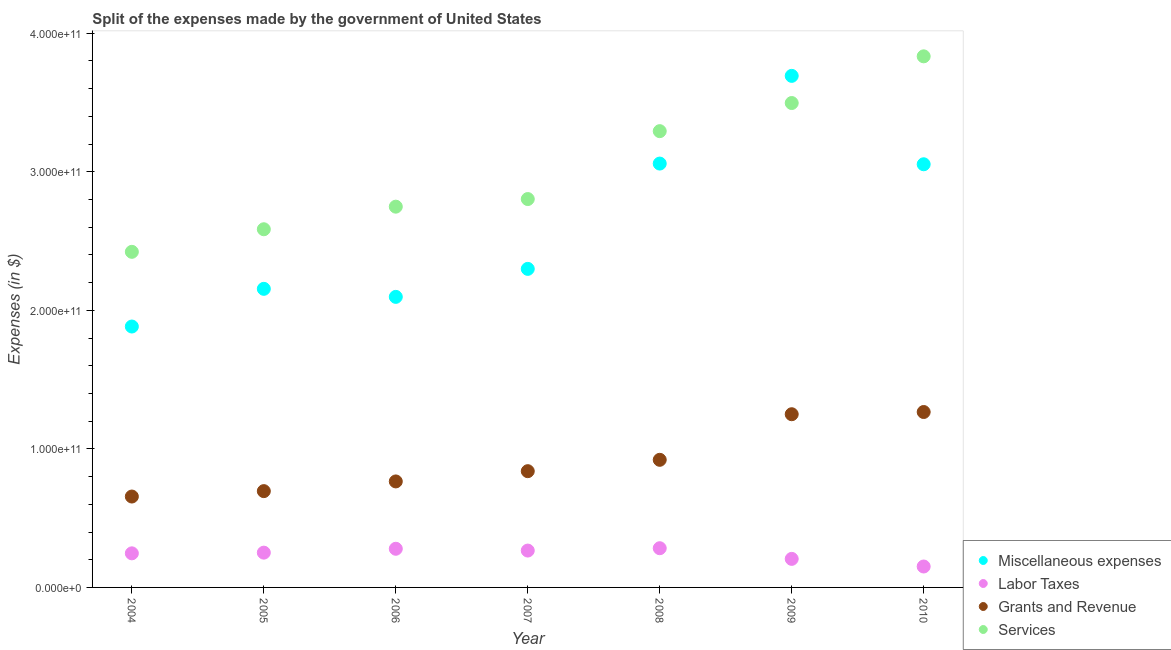What is the amount spent on services in 2007?
Your answer should be very brief. 2.80e+11. Across all years, what is the maximum amount spent on labor taxes?
Offer a very short reply. 2.83e+1. Across all years, what is the minimum amount spent on miscellaneous expenses?
Offer a terse response. 1.88e+11. In which year was the amount spent on grants and revenue maximum?
Your response must be concise. 2010. What is the total amount spent on grants and revenue in the graph?
Provide a succinct answer. 6.39e+11. What is the difference between the amount spent on miscellaneous expenses in 2005 and that in 2007?
Make the answer very short. -1.44e+1. What is the difference between the amount spent on miscellaneous expenses in 2007 and the amount spent on grants and revenue in 2006?
Offer a terse response. 1.53e+11. What is the average amount spent on labor taxes per year?
Offer a terse response. 2.40e+1. In the year 2004, what is the difference between the amount spent on grants and revenue and amount spent on miscellaneous expenses?
Your response must be concise. -1.23e+11. What is the ratio of the amount spent on services in 2004 to that in 2010?
Your response must be concise. 0.63. Is the amount spent on services in 2009 less than that in 2010?
Offer a very short reply. Yes. Is the difference between the amount spent on services in 2007 and 2008 greater than the difference between the amount spent on grants and revenue in 2007 and 2008?
Offer a terse response. No. What is the difference between the highest and the second highest amount spent on services?
Offer a terse response. 3.37e+1. What is the difference between the highest and the lowest amount spent on miscellaneous expenses?
Ensure brevity in your answer.  1.81e+11. Is it the case that in every year, the sum of the amount spent on services and amount spent on grants and revenue is greater than the sum of amount spent on miscellaneous expenses and amount spent on labor taxes?
Your response must be concise. Yes. Is it the case that in every year, the sum of the amount spent on miscellaneous expenses and amount spent on labor taxes is greater than the amount spent on grants and revenue?
Provide a succinct answer. Yes. Does the amount spent on grants and revenue monotonically increase over the years?
Your answer should be compact. Yes. Is the amount spent on labor taxes strictly greater than the amount spent on services over the years?
Keep it short and to the point. No. How many dotlines are there?
Your answer should be compact. 4. What is the difference between two consecutive major ticks on the Y-axis?
Your answer should be very brief. 1.00e+11. Are the values on the major ticks of Y-axis written in scientific E-notation?
Your answer should be compact. Yes. Does the graph contain grids?
Provide a succinct answer. No. Where does the legend appear in the graph?
Your answer should be compact. Bottom right. How are the legend labels stacked?
Keep it short and to the point. Vertical. What is the title of the graph?
Your response must be concise. Split of the expenses made by the government of United States. What is the label or title of the Y-axis?
Keep it short and to the point. Expenses (in $). What is the Expenses (in $) of Miscellaneous expenses in 2004?
Keep it short and to the point. 1.88e+11. What is the Expenses (in $) of Labor Taxes in 2004?
Give a very brief answer. 2.46e+1. What is the Expenses (in $) of Grants and Revenue in 2004?
Your answer should be very brief. 6.56e+1. What is the Expenses (in $) of Services in 2004?
Keep it short and to the point. 2.42e+11. What is the Expenses (in $) of Miscellaneous expenses in 2005?
Your answer should be compact. 2.16e+11. What is the Expenses (in $) of Labor Taxes in 2005?
Make the answer very short. 2.51e+1. What is the Expenses (in $) in Grants and Revenue in 2005?
Your answer should be compact. 6.95e+1. What is the Expenses (in $) in Services in 2005?
Make the answer very short. 2.58e+11. What is the Expenses (in $) of Miscellaneous expenses in 2006?
Provide a short and direct response. 2.10e+11. What is the Expenses (in $) of Labor Taxes in 2006?
Your answer should be very brief. 2.79e+1. What is the Expenses (in $) of Grants and Revenue in 2006?
Your answer should be very brief. 7.65e+1. What is the Expenses (in $) of Services in 2006?
Your response must be concise. 2.75e+11. What is the Expenses (in $) in Miscellaneous expenses in 2007?
Offer a very short reply. 2.30e+11. What is the Expenses (in $) of Labor Taxes in 2007?
Give a very brief answer. 2.66e+1. What is the Expenses (in $) of Grants and Revenue in 2007?
Your response must be concise. 8.39e+1. What is the Expenses (in $) in Services in 2007?
Offer a very short reply. 2.80e+11. What is the Expenses (in $) of Miscellaneous expenses in 2008?
Your response must be concise. 3.06e+11. What is the Expenses (in $) of Labor Taxes in 2008?
Provide a short and direct response. 2.83e+1. What is the Expenses (in $) in Grants and Revenue in 2008?
Your response must be concise. 9.21e+1. What is the Expenses (in $) of Services in 2008?
Give a very brief answer. 3.29e+11. What is the Expenses (in $) of Miscellaneous expenses in 2009?
Your response must be concise. 3.69e+11. What is the Expenses (in $) in Labor Taxes in 2009?
Keep it short and to the point. 2.06e+1. What is the Expenses (in $) of Grants and Revenue in 2009?
Your answer should be compact. 1.25e+11. What is the Expenses (in $) of Services in 2009?
Ensure brevity in your answer.  3.50e+11. What is the Expenses (in $) in Miscellaneous expenses in 2010?
Ensure brevity in your answer.  3.05e+11. What is the Expenses (in $) in Labor Taxes in 2010?
Keep it short and to the point. 1.51e+1. What is the Expenses (in $) of Grants and Revenue in 2010?
Offer a terse response. 1.27e+11. What is the Expenses (in $) in Services in 2010?
Give a very brief answer. 3.83e+11. Across all years, what is the maximum Expenses (in $) in Miscellaneous expenses?
Give a very brief answer. 3.69e+11. Across all years, what is the maximum Expenses (in $) in Labor Taxes?
Provide a short and direct response. 2.83e+1. Across all years, what is the maximum Expenses (in $) in Grants and Revenue?
Provide a short and direct response. 1.27e+11. Across all years, what is the maximum Expenses (in $) in Services?
Your answer should be very brief. 3.83e+11. Across all years, what is the minimum Expenses (in $) in Miscellaneous expenses?
Make the answer very short. 1.88e+11. Across all years, what is the minimum Expenses (in $) of Labor Taxes?
Keep it short and to the point. 1.51e+1. Across all years, what is the minimum Expenses (in $) in Grants and Revenue?
Keep it short and to the point. 6.56e+1. Across all years, what is the minimum Expenses (in $) in Services?
Provide a short and direct response. 2.42e+11. What is the total Expenses (in $) in Miscellaneous expenses in the graph?
Provide a succinct answer. 1.82e+12. What is the total Expenses (in $) of Labor Taxes in the graph?
Your response must be concise. 1.68e+11. What is the total Expenses (in $) of Grants and Revenue in the graph?
Provide a succinct answer. 6.39e+11. What is the total Expenses (in $) of Services in the graph?
Offer a very short reply. 2.12e+12. What is the difference between the Expenses (in $) of Miscellaneous expenses in 2004 and that in 2005?
Provide a succinct answer. -2.72e+1. What is the difference between the Expenses (in $) of Labor Taxes in 2004 and that in 2005?
Provide a short and direct response. -5.00e+08. What is the difference between the Expenses (in $) of Grants and Revenue in 2004 and that in 2005?
Make the answer very short. -3.90e+09. What is the difference between the Expenses (in $) of Services in 2004 and that in 2005?
Provide a short and direct response. -1.63e+1. What is the difference between the Expenses (in $) of Miscellaneous expenses in 2004 and that in 2006?
Offer a very short reply. -2.14e+1. What is the difference between the Expenses (in $) in Labor Taxes in 2004 and that in 2006?
Make the answer very short. -3.30e+09. What is the difference between the Expenses (in $) in Grants and Revenue in 2004 and that in 2006?
Make the answer very short. -1.09e+1. What is the difference between the Expenses (in $) of Services in 2004 and that in 2006?
Your response must be concise. -3.26e+1. What is the difference between the Expenses (in $) in Miscellaneous expenses in 2004 and that in 2007?
Your answer should be very brief. -4.16e+1. What is the difference between the Expenses (in $) in Labor Taxes in 2004 and that in 2007?
Your answer should be compact. -2.00e+09. What is the difference between the Expenses (in $) in Grants and Revenue in 2004 and that in 2007?
Offer a very short reply. -1.83e+1. What is the difference between the Expenses (in $) in Services in 2004 and that in 2007?
Provide a succinct answer. -3.81e+1. What is the difference between the Expenses (in $) of Miscellaneous expenses in 2004 and that in 2008?
Provide a short and direct response. -1.18e+11. What is the difference between the Expenses (in $) of Labor Taxes in 2004 and that in 2008?
Your response must be concise. -3.70e+09. What is the difference between the Expenses (in $) of Grants and Revenue in 2004 and that in 2008?
Offer a terse response. -2.65e+1. What is the difference between the Expenses (in $) of Services in 2004 and that in 2008?
Your answer should be compact. -8.71e+1. What is the difference between the Expenses (in $) of Miscellaneous expenses in 2004 and that in 2009?
Ensure brevity in your answer.  -1.81e+11. What is the difference between the Expenses (in $) of Labor Taxes in 2004 and that in 2009?
Provide a short and direct response. 4.00e+09. What is the difference between the Expenses (in $) of Grants and Revenue in 2004 and that in 2009?
Your response must be concise. -5.94e+1. What is the difference between the Expenses (in $) in Services in 2004 and that in 2009?
Your answer should be compact. -1.07e+11. What is the difference between the Expenses (in $) of Miscellaneous expenses in 2004 and that in 2010?
Your response must be concise. -1.17e+11. What is the difference between the Expenses (in $) in Labor Taxes in 2004 and that in 2010?
Make the answer very short. 9.50e+09. What is the difference between the Expenses (in $) in Grants and Revenue in 2004 and that in 2010?
Give a very brief answer. -6.10e+1. What is the difference between the Expenses (in $) in Services in 2004 and that in 2010?
Give a very brief answer. -1.41e+11. What is the difference between the Expenses (in $) in Miscellaneous expenses in 2005 and that in 2006?
Provide a succinct answer. 5.80e+09. What is the difference between the Expenses (in $) of Labor Taxes in 2005 and that in 2006?
Your answer should be compact. -2.80e+09. What is the difference between the Expenses (in $) in Grants and Revenue in 2005 and that in 2006?
Your response must be concise. -7.00e+09. What is the difference between the Expenses (in $) in Services in 2005 and that in 2006?
Your response must be concise. -1.63e+1. What is the difference between the Expenses (in $) in Miscellaneous expenses in 2005 and that in 2007?
Offer a very short reply. -1.44e+1. What is the difference between the Expenses (in $) in Labor Taxes in 2005 and that in 2007?
Your answer should be compact. -1.50e+09. What is the difference between the Expenses (in $) in Grants and Revenue in 2005 and that in 2007?
Your answer should be very brief. -1.44e+1. What is the difference between the Expenses (in $) of Services in 2005 and that in 2007?
Offer a very short reply. -2.18e+1. What is the difference between the Expenses (in $) of Miscellaneous expenses in 2005 and that in 2008?
Give a very brief answer. -9.04e+1. What is the difference between the Expenses (in $) of Labor Taxes in 2005 and that in 2008?
Give a very brief answer. -3.20e+09. What is the difference between the Expenses (in $) in Grants and Revenue in 2005 and that in 2008?
Offer a terse response. -2.26e+1. What is the difference between the Expenses (in $) of Services in 2005 and that in 2008?
Ensure brevity in your answer.  -7.08e+1. What is the difference between the Expenses (in $) in Miscellaneous expenses in 2005 and that in 2009?
Make the answer very short. -1.54e+11. What is the difference between the Expenses (in $) of Labor Taxes in 2005 and that in 2009?
Offer a terse response. 4.50e+09. What is the difference between the Expenses (in $) of Grants and Revenue in 2005 and that in 2009?
Provide a short and direct response. -5.55e+1. What is the difference between the Expenses (in $) in Services in 2005 and that in 2009?
Ensure brevity in your answer.  -9.11e+1. What is the difference between the Expenses (in $) of Miscellaneous expenses in 2005 and that in 2010?
Give a very brief answer. -8.99e+1. What is the difference between the Expenses (in $) of Grants and Revenue in 2005 and that in 2010?
Give a very brief answer. -5.71e+1. What is the difference between the Expenses (in $) of Services in 2005 and that in 2010?
Provide a succinct answer. -1.25e+11. What is the difference between the Expenses (in $) of Miscellaneous expenses in 2006 and that in 2007?
Provide a short and direct response. -2.02e+1. What is the difference between the Expenses (in $) in Labor Taxes in 2006 and that in 2007?
Keep it short and to the point. 1.30e+09. What is the difference between the Expenses (in $) of Grants and Revenue in 2006 and that in 2007?
Provide a succinct answer. -7.40e+09. What is the difference between the Expenses (in $) of Services in 2006 and that in 2007?
Offer a terse response. -5.50e+09. What is the difference between the Expenses (in $) in Miscellaneous expenses in 2006 and that in 2008?
Offer a terse response. -9.62e+1. What is the difference between the Expenses (in $) in Labor Taxes in 2006 and that in 2008?
Provide a short and direct response. -4.00e+08. What is the difference between the Expenses (in $) of Grants and Revenue in 2006 and that in 2008?
Provide a succinct answer. -1.56e+1. What is the difference between the Expenses (in $) of Services in 2006 and that in 2008?
Provide a succinct answer. -5.45e+1. What is the difference between the Expenses (in $) of Miscellaneous expenses in 2006 and that in 2009?
Ensure brevity in your answer.  -1.60e+11. What is the difference between the Expenses (in $) in Labor Taxes in 2006 and that in 2009?
Provide a succinct answer. 7.30e+09. What is the difference between the Expenses (in $) in Grants and Revenue in 2006 and that in 2009?
Offer a very short reply. -4.85e+1. What is the difference between the Expenses (in $) in Services in 2006 and that in 2009?
Ensure brevity in your answer.  -7.48e+1. What is the difference between the Expenses (in $) in Miscellaneous expenses in 2006 and that in 2010?
Your response must be concise. -9.57e+1. What is the difference between the Expenses (in $) in Labor Taxes in 2006 and that in 2010?
Your answer should be very brief. 1.28e+1. What is the difference between the Expenses (in $) in Grants and Revenue in 2006 and that in 2010?
Offer a very short reply. -5.01e+1. What is the difference between the Expenses (in $) in Services in 2006 and that in 2010?
Ensure brevity in your answer.  -1.08e+11. What is the difference between the Expenses (in $) of Miscellaneous expenses in 2007 and that in 2008?
Your answer should be compact. -7.60e+1. What is the difference between the Expenses (in $) of Labor Taxes in 2007 and that in 2008?
Provide a succinct answer. -1.70e+09. What is the difference between the Expenses (in $) of Grants and Revenue in 2007 and that in 2008?
Provide a succinct answer. -8.20e+09. What is the difference between the Expenses (in $) in Services in 2007 and that in 2008?
Provide a short and direct response. -4.90e+1. What is the difference between the Expenses (in $) in Miscellaneous expenses in 2007 and that in 2009?
Provide a succinct answer. -1.39e+11. What is the difference between the Expenses (in $) in Labor Taxes in 2007 and that in 2009?
Your answer should be very brief. 6.00e+09. What is the difference between the Expenses (in $) of Grants and Revenue in 2007 and that in 2009?
Provide a short and direct response. -4.11e+1. What is the difference between the Expenses (in $) of Services in 2007 and that in 2009?
Your answer should be compact. -6.93e+1. What is the difference between the Expenses (in $) of Miscellaneous expenses in 2007 and that in 2010?
Offer a very short reply. -7.55e+1. What is the difference between the Expenses (in $) in Labor Taxes in 2007 and that in 2010?
Your answer should be compact. 1.15e+1. What is the difference between the Expenses (in $) in Grants and Revenue in 2007 and that in 2010?
Provide a short and direct response. -4.27e+1. What is the difference between the Expenses (in $) in Services in 2007 and that in 2010?
Your response must be concise. -1.03e+11. What is the difference between the Expenses (in $) of Miscellaneous expenses in 2008 and that in 2009?
Make the answer very short. -6.33e+1. What is the difference between the Expenses (in $) of Labor Taxes in 2008 and that in 2009?
Your answer should be compact. 7.70e+09. What is the difference between the Expenses (in $) in Grants and Revenue in 2008 and that in 2009?
Your response must be concise. -3.29e+1. What is the difference between the Expenses (in $) in Services in 2008 and that in 2009?
Make the answer very short. -2.03e+1. What is the difference between the Expenses (in $) in Labor Taxes in 2008 and that in 2010?
Provide a short and direct response. 1.32e+1. What is the difference between the Expenses (in $) in Grants and Revenue in 2008 and that in 2010?
Make the answer very short. -3.45e+1. What is the difference between the Expenses (in $) of Services in 2008 and that in 2010?
Make the answer very short. -5.40e+1. What is the difference between the Expenses (in $) of Miscellaneous expenses in 2009 and that in 2010?
Make the answer very short. 6.38e+1. What is the difference between the Expenses (in $) in Labor Taxes in 2009 and that in 2010?
Your answer should be compact. 5.50e+09. What is the difference between the Expenses (in $) of Grants and Revenue in 2009 and that in 2010?
Keep it short and to the point. -1.60e+09. What is the difference between the Expenses (in $) in Services in 2009 and that in 2010?
Your response must be concise. -3.37e+1. What is the difference between the Expenses (in $) in Miscellaneous expenses in 2004 and the Expenses (in $) in Labor Taxes in 2005?
Your answer should be compact. 1.63e+11. What is the difference between the Expenses (in $) in Miscellaneous expenses in 2004 and the Expenses (in $) in Grants and Revenue in 2005?
Ensure brevity in your answer.  1.19e+11. What is the difference between the Expenses (in $) in Miscellaneous expenses in 2004 and the Expenses (in $) in Services in 2005?
Your answer should be compact. -7.02e+1. What is the difference between the Expenses (in $) in Labor Taxes in 2004 and the Expenses (in $) in Grants and Revenue in 2005?
Offer a very short reply. -4.49e+1. What is the difference between the Expenses (in $) in Labor Taxes in 2004 and the Expenses (in $) in Services in 2005?
Make the answer very short. -2.34e+11. What is the difference between the Expenses (in $) in Grants and Revenue in 2004 and the Expenses (in $) in Services in 2005?
Your response must be concise. -1.93e+11. What is the difference between the Expenses (in $) of Miscellaneous expenses in 2004 and the Expenses (in $) of Labor Taxes in 2006?
Provide a succinct answer. 1.60e+11. What is the difference between the Expenses (in $) of Miscellaneous expenses in 2004 and the Expenses (in $) of Grants and Revenue in 2006?
Offer a terse response. 1.12e+11. What is the difference between the Expenses (in $) in Miscellaneous expenses in 2004 and the Expenses (in $) in Services in 2006?
Make the answer very short. -8.65e+1. What is the difference between the Expenses (in $) of Labor Taxes in 2004 and the Expenses (in $) of Grants and Revenue in 2006?
Offer a very short reply. -5.19e+1. What is the difference between the Expenses (in $) in Labor Taxes in 2004 and the Expenses (in $) in Services in 2006?
Give a very brief answer. -2.50e+11. What is the difference between the Expenses (in $) in Grants and Revenue in 2004 and the Expenses (in $) in Services in 2006?
Your response must be concise. -2.09e+11. What is the difference between the Expenses (in $) in Miscellaneous expenses in 2004 and the Expenses (in $) in Labor Taxes in 2007?
Your answer should be very brief. 1.62e+11. What is the difference between the Expenses (in $) in Miscellaneous expenses in 2004 and the Expenses (in $) in Grants and Revenue in 2007?
Make the answer very short. 1.04e+11. What is the difference between the Expenses (in $) of Miscellaneous expenses in 2004 and the Expenses (in $) of Services in 2007?
Keep it short and to the point. -9.20e+1. What is the difference between the Expenses (in $) of Labor Taxes in 2004 and the Expenses (in $) of Grants and Revenue in 2007?
Give a very brief answer. -5.93e+1. What is the difference between the Expenses (in $) in Labor Taxes in 2004 and the Expenses (in $) in Services in 2007?
Provide a short and direct response. -2.56e+11. What is the difference between the Expenses (in $) in Grants and Revenue in 2004 and the Expenses (in $) in Services in 2007?
Your response must be concise. -2.15e+11. What is the difference between the Expenses (in $) in Miscellaneous expenses in 2004 and the Expenses (in $) in Labor Taxes in 2008?
Your response must be concise. 1.60e+11. What is the difference between the Expenses (in $) of Miscellaneous expenses in 2004 and the Expenses (in $) of Grants and Revenue in 2008?
Your answer should be very brief. 9.62e+1. What is the difference between the Expenses (in $) of Miscellaneous expenses in 2004 and the Expenses (in $) of Services in 2008?
Ensure brevity in your answer.  -1.41e+11. What is the difference between the Expenses (in $) of Labor Taxes in 2004 and the Expenses (in $) of Grants and Revenue in 2008?
Provide a succinct answer. -6.75e+1. What is the difference between the Expenses (in $) of Labor Taxes in 2004 and the Expenses (in $) of Services in 2008?
Your answer should be compact. -3.05e+11. What is the difference between the Expenses (in $) in Grants and Revenue in 2004 and the Expenses (in $) in Services in 2008?
Your answer should be very brief. -2.64e+11. What is the difference between the Expenses (in $) in Miscellaneous expenses in 2004 and the Expenses (in $) in Labor Taxes in 2009?
Ensure brevity in your answer.  1.68e+11. What is the difference between the Expenses (in $) in Miscellaneous expenses in 2004 and the Expenses (in $) in Grants and Revenue in 2009?
Offer a terse response. 6.33e+1. What is the difference between the Expenses (in $) in Miscellaneous expenses in 2004 and the Expenses (in $) in Services in 2009?
Give a very brief answer. -1.61e+11. What is the difference between the Expenses (in $) in Labor Taxes in 2004 and the Expenses (in $) in Grants and Revenue in 2009?
Offer a very short reply. -1.00e+11. What is the difference between the Expenses (in $) of Labor Taxes in 2004 and the Expenses (in $) of Services in 2009?
Your response must be concise. -3.25e+11. What is the difference between the Expenses (in $) in Grants and Revenue in 2004 and the Expenses (in $) in Services in 2009?
Give a very brief answer. -2.84e+11. What is the difference between the Expenses (in $) in Miscellaneous expenses in 2004 and the Expenses (in $) in Labor Taxes in 2010?
Make the answer very short. 1.73e+11. What is the difference between the Expenses (in $) in Miscellaneous expenses in 2004 and the Expenses (in $) in Grants and Revenue in 2010?
Make the answer very short. 6.17e+1. What is the difference between the Expenses (in $) in Miscellaneous expenses in 2004 and the Expenses (in $) in Services in 2010?
Offer a very short reply. -1.95e+11. What is the difference between the Expenses (in $) of Labor Taxes in 2004 and the Expenses (in $) of Grants and Revenue in 2010?
Give a very brief answer. -1.02e+11. What is the difference between the Expenses (in $) of Labor Taxes in 2004 and the Expenses (in $) of Services in 2010?
Offer a terse response. -3.59e+11. What is the difference between the Expenses (in $) of Grants and Revenue in 2004 and the Expenses (in $) of Services in 2010?
Your answer should be very brief. -3.18e+11. What is the difference between the Expenses (in $) in Miscellaneous expenses in 2005 and the Expenses (in $) in Labor Taxes in 2006?
Give a very brief answer. 1.88e+11. What is the difference between the Expenses (in $) of Miscellaneous expenses in 2005 and the Expenses (in $) of Grants and Revenue in 2006?
Your answer should be compact. 1.39e+11. What is the difference between the Expenses (in $) in Miscellaneous expenses in 2005 and the Expenses (in $) in Services in 2006?
Ensure brevity in your answer.  -5.93e+1. What is the difference between the Expenses (in $) in Labor Taxes in 2005 and the Expenses (in $) in Grants and Revenue in 2006?
Offer a terse response. -5.14e+1. What is the difference between the Expenses (in $) of Labor Taxes in 2005 and the Expenses (in $) of Services in 2006?
Your answer should be compact. -2.50e+11. What is the difference between the Expenses (in $) of Grants and Revenue in 2005 and the Expenses (in $) of Services in 2006?
Make the answer very short. -2.05e+11. What is the difference between the Expenses (in $) of Miscellaneous expenses in 2005 and the Expenses (in $) of Labor Taxes in 2007?
Give a very brief answer. 1.89e+11. What is the difference between the Expenses (in $) of Miscellaneous expenses in 2005 and the Expenses (in $) of Grants and Revenue in 2007?
Provide a succinct answer. 1.32e+11. What is the difference between the Expenses (in $) in Miscellaneous expenses in 2005 and the Expenses (in $) in Services in 2007?
Ensure brevity in your answer.  -6.48e+1. What is the difference between the Expenses (in $) in Labor Taxes in 2005 and the Expenses (in $) in Grants and Revenue in 2007?
Your answer should be compact. -5.88e+1. What is the difference between the Expenses (in $) of Labor Taxes in 2005 and the Expenses (in $) of Services in 2007?
Ensure brevity in your answer.  -2.55e+11. What is the difference between the Expenses (in $) of Grants and Revenue in 2005 and the Expenses (in $) of Services in 2007?
Provide a short and direct response. -2.11e+11. What is the difference between the Expenses (in $) in Miscellaneous expenses in 2005 and the Expenses (in $) in Labor Taxes in 2008?
Your answer should be very brief. 1.87e+11. What is the difference between the Expenses (in $) in Miscellaneous expenses in 2005 and the Expenses (in $) in Grants and Revenue in 2008?
Offer a very short reply. 1.23e+11. What is the difference between the Expenses (in $) in Miscellaneous expenses in 2005 and the Expenses (in $) in Services in 2008?
Your answer should be compact. -1.14e+11. What is the difference between the Expenses (in $) in Labor Taxes in 2005 and the Expenses (in $) in Grants and Revenue in 2008?
Your answer should be very brief. -6.70e+1. What is the difference between the Expenses (in $) of Labor Taxes in 2005 and the Expenses (in $) of Services in 2008?
Provide a short and direct response. -3.04e+11. What is the difference between the Expenses (in $) in Grants and Revenue in 2005 and the Expenses (in $) in Services in 2008?
Give a very brief answer. -2.60e+11. What is the difference between the Expenses (in $) of Miscellaneous expenses in 2005 and the Expenses (in $) of Labor Taxes in 2009?
Provide a short and direct response. 1.95e+11. What is the difference between the Expenses (in $) in Miscellaneous expenses in 2005 and the Expenses (in $) in Grants and Revenue in 2009?
Give a very brief answer. 9.05e+1. What is the difference between the Expenses (in $) in Miscellaneous expenses in 2005 and the Expenses (in $) in Services in 2009?
Make the answer very short. -1.34e+11. What is the difference between the Expenses (in $) of Labor Taxes in 2005 and the Expenses (in $) of Grants and Revenue in 2009?
Keep it short and to the point. -9.99e+1. What is the difference between the Expenses (in $) of Labor Taxes in 2005 and the Expenses (in $) of Services in 2009?
Ensure brevity in your answer.  -3.24e+11. What is the difference between the Expenses (in $) of Grants and Revenue in 2005 and the Expenses (in $) of Services in 2009?
Provide a short and direct response. -2.80e+11. What is the difference between the Expenses (in $) in Miscellaneous expenses in 2005 and the Expenses (in $) in Labor Taxes in 2010?
Your response must be concise. 2.00e+11. What is the difference between the Expenses (in $) of Miscellaneous expenses in 2005 and the Expenses (in $) of Grants and Revenue in 2010?
Ensure brevity in your answer.  8.89e+1. What is the difference between the Expenses (in $) of Miscellaneous expenses in 2005 and the Expenses (in $) of Services in 2010?
Offer a very short reply. -1.68e+11. What is the difference between the Expenses (in $) in Labor Taxes in 2005 and the Expenses (in $) in Grants and Revenue in 2010?
Give a very brief answer. -1.02e+11. What is the difference between the Expenses (in $) of Labor Taxes in 2005 and the Expenses (in $) of Services in 2010?
Your answer should be very brief. -3.58e+11. What is the difference between the Expenses (in $) of Grants and Revenue in 2005 and the Expenses (in $) of Services in 2010?
Offer a very short reply. -3.14e+11. What is the difference between the Expenses (in $) of Miscellaneous expenses in 2006 and the Expenses (in $) of Labor Taxes in 2007?
Keep it short and to the point. 1.83e+11. What is the difference between the Expenses (in $) of Miscellaneous expenses in 2006 and the Expenses (in $) of Grants and Revenue in 2007?
Offer a very short reply. 1.26e+11. What is the difference between the Expenses (in $) in Miscellaneous expenses in 2006 and the Expenses (in $) in Services in 2007?
Make the answer very short. -7.06e+1. What is the difference between the Expenses (in $) in Labor Taxes in 2006 and the Expenses (in $) in Grants and Revenue in 2007?
Your answer should be compact. -5.60e+1. What is the difference between the Expenses (in $) in Labor Taxes in 2006 and the Expenses (in $) in Services in 2007?
Give a very brief answer. -2.52e+11. What is the difference between the Expenses (in $) of Grants and Revenue in 2006 and the Expenses (in $) of Services in 2007?
Provide a short and direct response. -2.04e+11. What is the difference between the Expenses (in $) of Miscellaneous expenses in 2006 and the Expenses (in $) of Labor Taxes in 2008?
Provide a succinct answer. 1.81e+11. What is the difference between the Expenses (in $) in Miscellaneous expenses in 2006 and the Expenses (in $) in Grants and Revenue in 2008?
Give a very brief answer. 1.18e+11. What is the difference between the Expenses (in $) in Miscellaneous expenses in 2006 and the Expenses (in $) in Services in 2008?
Give a very brief answer. -1.20e+11. What is the difference between the Expenses (in $) of Labor Taxes in 2006 and the Expenses (in $) of Grants and Revenue in 2008?
Your response must be concise. -6.42e+1. What is the difference between the Expenses (in $) in Labor Taxes in 2006 and the Expenses (in $) in Services in 2008?
Your answer should be very brief. -3.01e+11. What is the difference between the Expenses (in $) in Grants and Revenue in 2006 and the Expenses (in $) in Services in 2008?
Give a very brief answer. -2.53e+11. What is the difference between the Expenses (in $) in Miscellaneous expenses in 2006 and the Expenses (in $) in Labor Taxes in 2009?
Provide a short and direct response. 1.89e+11. What is the difference between the Expenses (in $) in Miscellaneous expenses in 2006 and the Expenses (in $) in Grants and Revenue in 2009?
Offer a very short reply. 8.47e+1. What is the difference between the Expenses (in $) of Miscellaneous expenses in 2006 and the Expenses (in $) of Services in 2009?
Give a very brief answer. -1.40e+11. What is the difference between the Expenses (in $) in Labor Taxes in 2006 and the Expenses (in $) in Grants and Revenue in 2009?
Offer a terse response. -9.71e+1. What is the difference between the Expenses (in $) of Labor Taxes in 2006 and the Expenses (in $) of Services in 2009?
Offer a terse response. -3.22e+11. What is the difference between the Expenses (in $) of Grants and Revenue in 2006 and the Expenses (in $) of Services in 2009?
Provide a succinct answer. -2.73e+11. What is the difference between the Expenses (in $) in Miscellaneous expenses in 2006 and the Expenses (in $) in Labor Taxes in 2010?
Make the answer very short. 1.95e+11. What is the difference between the Expenses (in $) in Miscellaneous expenses in 2006 and the Expenses (in $) in Grants and Revenue in 2010?
Your answer should be compact. 8.31e+1. What is the difference between the Expenses (in $) in Miscellaneous expenses in 2006 and the Expenses (in $) in Services in 2010?
Your response must be concise. -1.74e+11. What is the difference between the Expenses (in $) in Labor Taxes in 2006 and the Expenses (in $) in Grants and Revenue in 2010?
Keep it short and to the point. -9.87e+1. What is the difference between the Expenses (in $) in Labor Taxes in 2006 and the Expenses (in $) in Services in 2010?
Keep it short and to the point. -3.55e+11. What is the difference between the Expenses (in $) of Grants and Revenue in 2006 and the Expenses (in $) of Services in 2010?
Your answer should be very brief. -3.07e+11. What is the difference between the Expenses (in $) in Miscellaneous expenses in 2007 and the Expenses (in $) in Labor Taxes in 2008?
Make the answer very short. 2.02e+11. What is the difference between the Expenses (in $) of Miscellaneous expenses in 2007 and the Expenses (in $) of Grants and Revenue in 2008?
Offer a very short reply. 1.38e+11. What is the difference between the Expenses (in $) in Miscellaneous expenses in 2007 and the Expenses (in $) in Services in 2008?
Keep it short and to the point. -9.94e+1. What is the difference between the Expenses (in $) in Labor Taxes in 2007 and the Expenses (in $) in Grants and Revenue in 2008?
Provide a short and direct response. -6.55e+1. What is the difference between the Expenses (in $) in Labor Taxes in 2007 and the Expenses (in $) in Services in 2008?
Make the answer very short. -3.03e+11. What is the difference between the Expenses (in $) of Grants and Revenue in 2007 and the Expenses (in $) of Services in 2008?
Your response must be concise. -2.45e+11. What is the difference between the Expenses (in $) of Miscellaneous expenses in 2007 and the Expenses (in $) of Labor Taxes in 2009?
Provide a short and direct response. 2.09e+11. What is the difference between the Expenses (in $) of Miscellaneous expenses in 2007 and the Expenses (in $) of Grants and Revenue in 2009?
Ensure brevity in your answer.  1.05e+11. What is the difference between the Expenses (in $) of Miscellaneous expenses in 2007 and the Expenses (in $) of Services in 2009?
Your answer should be compact. -1.20e+11. What is the difference between the Expenses (in $) in Labor Taxes in 2007 and the Expenses (in $) in Grants and Revenue in 2009?
Offer a very short reply. -9.84e+1. What is the difference between the Expenses (in $) in Labor Taxes in 2007 and the Expenses (in $) in Services in 2009?
Offer a terse response. -3.23e+11. What is the difference between the Expenses (in $) of Grants and Revenue in 2007 and the Expenses (in $) of Services in 2009?
Your response must be concise. -2.66e+11. What is the difference between the Expenses (in $) of Miscellaneous expenses in 2007 and the Expenses (in $) of Labor Taxes in 2010?
Make the answer very short. 2.15e+11. What is the difference between the Expenses (in $) of Miscellaneous expenses in 2007 and the Expenses (in $) of Grants and Revenue in 2010?
Keep it short and to the point. 1.03e+11. What is the difference between the Expenses (in $) in Miscellaneous expenses in 2007 and the Expenses (in $) in Services in 2010?
Make the answer very short. -1.53e+11. What is the difference between the Expenses (in $) in Labor Taxes in 2007 and the Expenses (in $) in Grants and Revenue in 2010?
Your answer should be very brief. -1.00e+11. What is the difference between the Expenses (in $) of Labor Taxes in 2007 and the Expenses (in $) of Services in 2010?
Offer a terse response. -3.57e+11. What is the difference between the Expenses (in $) of Grants and Revenue in 2007 and the Expenses (in $) of Services in 2010?
Keep it short and to the point. -2.99e+11. What is the difference between the Expenses (in $) of Miscellaneous expenses in 2008 and the Expenses (in $) of Labor Taxes in 2009?
Offer a very short reply. 2.85e+11. What is the difference between the Expenses (in $) of Miscellaneous expenses in 2008 and the Expenses (in $) of Grants and Revenue in 2009?
Offer a very short reply. 1.81e+11. What is the difference between the Expenses (in $) of Miscellaneous expenses in 2008 and the Expenses (in $) of Services in 2009?
Your answer should be very brief. -4.37e+1. What is the difference between the Expenses (in $) in Labor Taxes in 2008 and the Expenses (in $) in Grants and Revenue in 2009?
Offer a very short reply. -9.67e+1. What is the difference between the Expenses (in $) of Labor Taxes in 2008 and the Expenses (in $) of Services in 2009?
Your answer should be compact. -3.21e+11. What is the difference between the Expenses (in $) in Grants and Revenue in 2008 and the Expenses (in $) in Services in 2009?
Provide a succinct answer. -2.58e+11. What is the difference between the Expenses (in $) in Miscellaneous expenses in 2008 and the Expenses (in $) in Labor Taxes in 2010?
Keep it short and to the point. 2.91e+11. What is the difference between the Expenses (in $) of Miscellaneous expenses in 2008 and the Expenses (in $) of Grants and Revenue in 2010?
Offer a terse response. 1.79e+11. What is the difference between the Expenses (in $) of Miscellaneous expenses in 2008 and the Expenses (in $) of Services in 2010?
Make the answer very short. -7.74e+1. What is the difference between the Expenses (in $) of Labor Taxes in 2008 and the Expenses (in $) of Grants and Revenue in 2010?
Ensure brevity in your answer.  -9.83e+1. What is the difference between the Expenses (in $) of Labor Taxes in 2008 and the Expenses (in $) of Services in 2010?
Give a very brief answer. -3.55e+11. What is the difference between the Expenses (in $) of Grants and Revenue in 2008 and the Expenses (in $) of Services in 2010?
Give a very brief answer. -2.91e+11. What is the difference between the Expenses (in $) of Miscellaneous expenses in 2009 and the Expenses (in $) of Labor Taxes in 2010?
Provide a succinct answer. 3.54e+11. What is the difference between the Expenses (in $) of Miscellaneous expenses in 2009 and the Expenses (in $) of Grants and Revenue in 2010?
Keep it short and to the point. 2.43e+11. What is the difference between the Expenses (in $) in Miscellaneous expenses in 2009 and the Expenses (in $) in Services in 2010?
Ensure brevity in your answer.  -1.41e+1. What is the difference between the Expenses (in $) in Labor Taxes in 2009 and the Expenses (in $) in Grants and Revenue in 2010?
Your response must be concise. -1.06e+11. What is the difference between the Expenses (in $) in Labor Taxes in 2009 and the Expenses (in $) in Services in 2010?
Give a very brief answer. -3.63e+11. What is the difference between the Expenses (in $) in Grants and Revenue in 2009 and the Expenses (in $) in Services in 2010?
Keep it short and to the point. -2.58e+11. What is the average Expenses (in $) of Miscellaneous expenses per year?
Your answer should be compact. 2.61e+11. What is the average Expenses (in $) in Labor Taxes per year?
Make the answer very short. 2.40e+1. What is the average Expenses (in $) in Grants and Revenue per year?
Offer a terse response. 9.13e+1. What is the average Expenses (in $) of Services per year?
Keep it short and to the point. 3.03e+11. In the year 2004, what is the difference between the Expenses (in $) of Miscellaneous expenses and Expenses (in $) of Labor Taxes?
Offer a terse response. 1.64e+11. In the year 2004, what is the difference between the Expenses (in $) in Miscellaneous expenses and Expenses (in $) in Grants and Revenue?
Keep it short and to the point. 1.23e+11. In the year 2004, what is the difference between the Expenses (in $) of Miscellaneous expenses and Expenses (in $) of Services?
Offer a very short reply. -5.39e+1. In the year 2004, what is the difference between the Expenses (in $) of Labor Taxes and Expenses (in $) of Grants and Revenue?
Keep it short and to the point. -4.10e+1. In the year 2004, what is the difference between the Expenses (in $) of Labor Taxes and Expenses (in $) of Services?
Offer a terse response. -2.18e+11. In the year 2004, what is the difference between the Expenses (in $) in Grants and Revenue and Expenses (in $) in Services?
Make the answer very short. -1.77e+11. In the year 2005, what is the difference between the Expenses (in $) of Miscellaneous expenses and Expenses (in $) of Labor Taxes?
Offer a very short reply. 1.90e+11. In the year 2005, what is the difference between the Expenses (in $) in Miscellaneous expenses and Expenses (in $) in Grants and Revenue?
Make the answer very short. 1.46e+11. In the year 2005, what is the difference between the Expenses (in $) of Miscellaneous expenses and Expenses (in $) of Services?
Offer a very short reply. -4.30e+1. In the year 2005, what is the difference between the Expenses (in $) of Labor Taxes and Expenses (in $) of Grants and Revenue?
Offer a very short reply. -4.44e+1. In the year 2005, what is the difference between the Expenses (in $) in Labor Taxes and Expenses (in $) in Services?
Give a very brief answer. -2.33e+11. In the year 2005, what is the difference between the Expenses (in $) in Grants and Revenue and Expenses (in $) in Services?
Keep it short and to the point. -1.89e+11. In the year 2006, what is the difference between the Expenses (in $) of Miscellaneous expenses and Expenses (in $) of Labor Taxes?
Offer a very short reply. 1.82e+11. In the year 2006, what is the difference between the Expenses (in $) of Miscellaneous expenses and Expenses (in $) of Grants and Revenue?
Keep it short and to the point. 1.33e+11. In the year 2006, what is the difference between the Expenses (in $) of Miscellaneous expenses and Expenses (in $) of Services?
Provide a short and direct response. -6.51e+1. In the year 2006, what is the difference between the Expenses (in $) of Labor Taxes and Expenses (in $) of Grants and Revenue?
Your response must be concise. -4.86e+1. In the year 2006, what is the difference between the Expenses (in $) of Labor Taxes and Expenses (in $) of Services?
Your answer should be very brief. -2.47e+11. In the year 2006, what is the difference between the Expenses (in $) of Grants and Revenue and Expenses (in $) of Services?
Give a very brief answer. -1.98e+11. In the year 2007, what is the difference between the Expenses (in $) of Miscellaneous expenses and Expenses (in $) of Labor Taxes?
Your response must be concise. 2.03e+11. In the year 2007, what is the difference between the Expenses (in $) in Miscellaneous expenses and Expenses (in $) in Grants and Revenue?
Your answer should be compact. 1.46e+11. In the year 2007, what is the difference between the Expenses (in $) in Miscellaneous expenses and Expenses (in $) in Services?
Offer a very short reply. -5.04e+1. In the year 2007, what is the difference between the Expenses (in $) in Labor Taxes and Expenses (in $) in Grants and Revenue?
Make the answer very short. -5.73e+1. In the year 2007, what is the difference between the Expenses (in $) of Labor Taxes and Expenses (in $) of Services?
Keep it short and to the point. -2.54e+11. In the year 2007, what is the difference between the Expenses (in $) of Grants and Revenue and Expenses (in $) of Services?
Your answer should be very brief. -1.96e+11. In the year 2008, what is the difference between the Expenses (in $) in Miscellaneous expenses and Expenses (in $) in Labor Taxes?
Offer a terse response. 2.78e+11. In the year 2008, what is the difference between the Expenses (in $) of Miscellaneous expenses and Expenses (in $) of Grants and Revenue?
Your response must be concise. 2.14e+11. In the year 2008, what is the difference between the Expenses (in $) of Miscellaneous expenses and Expenses (in $) of Services?
Offer a terse response. -2.34e+1. In the year 2008, what is the difference between the Expenses (in $) of Labor Taxes and Expenses (in $) of Grants and Revenue?
Keep it short and to the point. -6.38e+1. In the year 2008, what is the difference between the Expenses (in $) of Labor Taxes and Expenses (in $) of Services?
Provide a short and direct response. -3.01e+11. In the year 2008, what is the difference between the Expenses (in $) in Grants and Revenue and Expenses (in $) in Services?
Your answer should be very brief. -2.37e+11. In the year 2009, what is the difference between the Expenses (in $) in Miscellaneous expenses and Expenses (in $) in Labor Taxes?
Keep it short and to the point. 3.49e+11. In the year 2009, what is the difference between the Expenses (in $) of Miscellaneous expenses and Expenses (in $) of Grants and Revenue?
Your answer should be very brief. 2.44e+11. In the year 2009, what is the difference between the Expenses (in $) in Miscellaneous expenses and Expenses (in $) in Services?
Provide a short and direct response. 1.96e+1. In the year 2009, what is the difference between the Expenses (in $) in Labor Taxes and Expenses (in $) in Grants and Revenue?
Your response must be concise. -1.04e+11. In the year 2009, what is the difference between the Expenses (in $) in Labor Taxes and Expenses (in $) in Services?
Give a very brief answer. -3.29e+11. In the year 2009, what is the difference between the Expenses (in $) of Grants and Revenue and Expenses (in $) of Services?
Your answer should be very brief. -2.25e+11. In the year 2010, what is the difference between the Expenses (in $) in Miscellaneous expenses and Expenses (in $) in Labor Taxes?
Make the answer very short. 2.90e+11. In the year 2010, what is the difference between the Expenses (in $) in Miscellaneous expenses and Expenses (in $) in Grants and Revenue?
Your answer should be very brief. 1.79e+11. In the year 2010, what is the difference between the Expenses (in $) of Miscellaneous expenses and Expenses (in $) of Services?
Provide a succinct answer. -7.79e+1. In the year 2010, what is the difference between the Expenses (in $) of Labor Taxes and Expenses (in $) of Grants and Revenue?
Your answer should be compact. -1.12e+11. In the year 2010, what is the difference between the Expenses (in $) of Labor Taxes and Expenses (in $) of Services?
Ensure brevity in your answer.  -3.68e+11. In the year 2010, what is the difference between the Expenses (in $) of Grants and Revenue and Expenses (in $) of Services?
Offer a very short reply. -2.57e+11. What is the ratio of the Expenses (in $) of Miscellaneous expenses in 2004 to that in 2005?
Give a very brief answer. 0.87. What is the ratio of the Expenses (in $) in Labor Taxes in 2004 to that in 2005?
Offer a terse response. 0.98. What is the ratio of the Expenses (in $) in Grants and Revenue in 2004 to that in 2005?
Give a very brief answer. 0.94. What is the ratio of the Expenses (in $) in Services in 2004 to that in 2005?
Give a very brief answer. 0.94. What is the ratio of the Expenses (in $) of Miscellaneous expenses in 2004 to that in 2006?
Provide a short and direct response. 0.9. What is the ratio of the Expenses (in $) in Labor Taxes in 2004 to that in 2006?
Your response must be concise. 0.88. What is the ratio of the Expenses (in $) of Grants and Revenue in 2004 to that in 2006?
Keep it short and to the point. 0.86. What is the ratio of the Expenses (in $) of Services in 2004 to that in 2006?
Make the answer very short. 0.88. What is the ratio of the Expenses (in $) of Miscellaneous expenses in 2004 to that in 2007?
Give a very brief answer. 0.82. What is the ratio of the Expenses (in $) in Labor Taxes in 2004 to that in 2007?
Ensure brevity in your answer.  0.92. What is the ratio of the Expenses (in $) of Grants and Revenue in 2004 to that in 2007?
Provide a succinct answer. 0.78. What is the ratio of the Expenses (in $) of Services in 2004 to that in 2007?
Your answer should be compact. 0.86. What is the ratio of the Expenses (in $) of Miscellaneous expenses in 2004 to that in 2008?
Provide a short and direct response. 0.62. What is the ratio of the Expenses (in $) in Labor Taxes in 2004 to that in 2008?
Give a very brief answer. 0.87. What is the ratio of the Expenses (in $) in Grants and Revenue in 2004 to that in 2008?
Provide a short and direct response. 0.71. What is the ratio of the Expenses (in $) of Services in 2004 to that in 2008?
Your response must be concise. 0.74. What is the ratio of the Expenses (in $) in Miscellaneous expenses in 2004 to that in 2009?
Give a very brief answer. 0.51. What is the ratio of the Expenses (in $) in Labor Taxes in 2004 to that in 2009?
Provide a short and direct response. 1.19. What is the ratio of the Expenses (in $) in Grants and Revenue in 2004 to that in 2009?
Your answer should be compact. 0.52. What is the ratio of the Expenses (in $) in Services in 2004 to that in 2009?
Offer a terse response. 0.69. What is the ratio of the Expenses (in $) of Miscellaneous expenses in 2004 to that in 2010?
Your answer should be compact. 0.62. What is the ratio of the Expenses (in $) of Labor Taxes in 2004 to that in 2010?
Offer a very short reply. 1.63. What is the ratio of the Expenses (in $) in Grants and Revenue in 2004 to that in 2010?
Give a very brief answer. 0.52. What is the ratio of the Expenses (in $) in Services in 2004 to that in 2010?
Offer a very short reply. 0.63. What is the ratio of the Expenses (in $) in Miscellaneous expenses in 2005 to that in 2006?
Offer a terse response. 1.03. What is the ratio of the Expenses (in $) of Labor Taxes in 2005 to that in 2006?
Your answer should be compact. 0.9. What is the ratio of the Expenses (in $) of Grants and Revenue in 2005 to that in 2006?
Your answer should be very brief. 0.91. What is the ratio of the Expenses (in $) of Services in 2005 to that in 2006?
Provide a short and direct response. 0.94. What is the ratio of the Expenses (in $) of Miscellaneous expenses in 2005 to that in 2007?
Your response must be concise. 0.94. What is the ratio of the Expenses (in $) of Labor Taxes in 2005 to that in 2007?
Give a very brief answer. 0.94. What is the ratio of the Expenses (in $) in Grants and Revenue in 2005 to that in 2007?
Your answer should be very brief. 0.83. What is the ratio of the Expenses (in $) in Services in 2005 to that in 2007?
Ensure brevity in your answer.  0.92. What is the ratio of the Expenses (in $) in Miscellaneous expenses in 2005 to that in 2008?
Keep it short and to the point. 0.7. What is the ratio of the Expenses (in $) in Labor Taxes in 2005 to that in 2008?
Make the answer very short. 0.89. What is the ratio of the Expenses (in $) in Grants and Revenue in 2005 to that in 2008?
Ensure brevity in your answer.  0.75. What is the ratio of the Expenses (in $) of Services in 2005 to that in 2008?
Your answer should be compact. 0.79. What is the ratio of the Expenses (in $) of Miscellaneous expenses in 2005 to that in 2009?
Provide a short and direct response. 0.58. What is the ratio of the Expenses (in $) in Labor Taxes in 2005 to that in 2009?
Offer a terse response. 1.22. What is the ratio of the Expenses (in $) in Grants and Revenue in 2005 to that in 2009?
Your response must be concise. 0.56. What is the ratio of the Expenses (in $) of Services in 2005 to that in 2009?
Make the answer very short. 0.74. What is the ratio of the Expenses (in $) of Miscellaneous expenses in 2005 to that in 2010?
Provide a succinct answer. 0.71. What is the ratio of the Expenses (in $) of Labor Taxes in 2005 to that in 2010?
Keep it short and to the point. 1.66. What is the ratio of the Expenses (in $) of Grants and Revenue in 2005 to that in 2010?
Your answer should be very brief. 0.55. What is the ratio of the Expenses (in $) in Services in 2005 to that in 2010?
Ensure brevity in your answer.  0.67. What is the ratio of the Expenses (in $) of Miscellaneous expenses in 2006 to that in 2007?
Provide a short and direct response. 0.91. What is the ratio of the Expenses (in $) of Labor Taxes in 2006 to that in 2007?
Your response must be concise. 1.05. What is the ratio of the Expenses (in $) of Grants and Revenue in 2006 to that in 2007?
Offer a very short reply. 0.91. What is the ratio of the Expenses (in $) of Services in 2006 to that in 2007?
Your answer should be compact. 0.98. What is the ratio of the Expenses (in $) of Miscellaneous expenses in 2006 to that in 2008?
Provide a short and direct response. 0.69. What is the ratio of the Expenses (in $) in Labor Taxes in 2006 to that in 2008?
Offer a terse response. 0.99. What is the ratio of the Expenses (in $) of Grants and Revenue in 2006 to that in 2008?
Keep it short and to the point. 0.83. What is the ratio of the Expenses (in $) of Services in 2006 to that in 2008?
Offer a very short reply. 0.83. What is the ratio of the Expenses (in $) of Miscellaneous expenses in 2006 to that in 2009?
Give a very brief answer. 0.57. What is the ratio of the Expenses (in $) of Labor Taxes in 2006 to that in 2009?
Ensure brevity in your answer.  1.35. What is the ratio of the Expenses (in $) of Grants and Revenue in 2006 to that in 2009?
Your answer should be compact. 0.61. What is the ratio of the Expenses (in $) in Services in 2006 to that in 2009?
Ensure brevity in your answer.  0.79. What is the ratio of the Expenses (in $) of Miscellaneous expenses in 2006 to that in 2010?
Offer a very short reply. 0.69. What is the ratio of the Expenses (in $) in Labor Taxes in 2006 to that in 2010?
Your answer should be compact. 1.85. What is the ratio of the Expenses (in $) of Grants and Revenue in 2006 to that in 2010?
Offer a very short reply. 0.6. What is the ratio of the Expenses (in $) of Services in 2006 to that in 2010?
Make the answer very short. 0.72. What is the ratio of the Expenses (in $) in Miscellaneous expenses in 2007 to that in 2008?
Offer a very short reply. 0.75. What is the ratio of the Expenses (in $) in Labor Taxes in 2007 to that in 2008?
Make the answer very short. 0.94. What is the ratio of the Expenses (in $) of Grants and Revenue in 2007 to that in 2008?
Provide a succinct answer. 0.91. What is the ratio of the Expenses (in $) of Services in 2007 to that in 2008?
Provide a succinct answer. 0.85. What is the ratio of the Expenses (in $) of Miscellaneous expenses in 2007 to that in 2009?
Your answer should be very brief. 0.62. What is the ratio of the Expenses (in $) of Labor Taxes in 2007 to that in 2009?
Your response must be concise. 1.29. What is the ratio of the Expenses (in $) in Grants and Revenue in 2007 to that in 2009?
Your response must be concise. 0.67. What is the ratio of the Expenses (in $) in Services in 2007 to that in 2009?
Offer a very short reply. 0.8. What is the ratio of the Expenses (in $) in Miscellaneous expenses in 2007 to that in 2010?
Your response must be concise. 0.75. What is the ratio of the Expenses (in $) in Labor Taxes in 2007 to that in 2010?
Provide a succinct answer. 1.76. What is the ratio of the Expenses (in $) of Grants and Revenue in 2007 to that in 2010?
Keep it short and to the point. 0.66. What is the ratio of the Expenses (in $) of Services in 2007 to that in 2010?
Ensure brevity in your answer.  0.73. What is the ratio of the Expenses (in $) in Miscellaneous expenses in 2008 to that in 2009?
Your answer should be compact. 0.83. What is the ratio of the Expenses (in $) of Labor Taxes in 2008 to that in 2009?
Make the answer very short. 1.37. What is the ratio of the Expenses (in $) in Grants and Revenue in 2008 to that in 2009?
Give a very brief answer. 0.74. What is the ratio of the Expenses (in $) of Services in 2008 to that in 2009?
Provide a short and direct response. 0.94. What is the ratio of the Expenses (in $) of Miscellaneous expenses in 2008 to that in 2010?
Your response must be concise. 1. What is the ratio of the Expenses (in $) in Labor Taxes in 2008 to that in 2010?
Give a very brief answer. 1.87. What is the ratio of the Expenses (in $) of Grants and Revenue in 2008 to that in 2010?
Provide a succinct answer. 0.73. What is the ratio of the Expenses (in $) in Services in 2008 to that in 2010?
Your answer should be very brief. 0.86. What is the ratio of the Expenses (in $) in Miscellaneous expenses in 2009 to that in 2010?
Give a very brief answer. 1.21. What is the ratio of the Expenses (in $) in Labor Taxes in 2009 to that in 2010?
Offer a terse response. 1.36. What is the ratio of the Expenses (in $) in Grants and Revenue in 2009 to that in 2010?
Offer a very short reply. 0.99. What is the ratio of the Expenses (in $) of Services in 2009 to that in 2010?
Your answer should be very brief. 0.91. What is the difference between the highest and the second highest Expenses (in $) of Miscellaneous expenses?
Your response must be concise. 6.33e+1. What is the difference between the highest and the second highest Expenses (in $) of Labor Taxes?
Your response must be concise. 4.00e+08. What is the difference between the highest and the second highest Expenses (in $) of Grants and Revenue?
Your answer should be very brief. 1.60e+09. What is the difference between the highest and the second highest Expenses (in $) of Services?
Your answer should be compact. 3.37e+1. What is the difference between the highest and the lowest Expenses (in $) in Miscellaneous expenses?
Offer a very short reply. 1.81e+11. What is the difference between the highest and the lowest Expenses (in $) of Labor Taxes?
Offer a very short reply. 1.32e+1. What is the difference between the highest and the lowest Expenses (in $) of Grants and Revenue?
Make the answer very short. 6.10e+1. What is the difference between the highest and the lowest Expenses (in $) in Services?
Your answer should be very brief. 1.41e+11. 